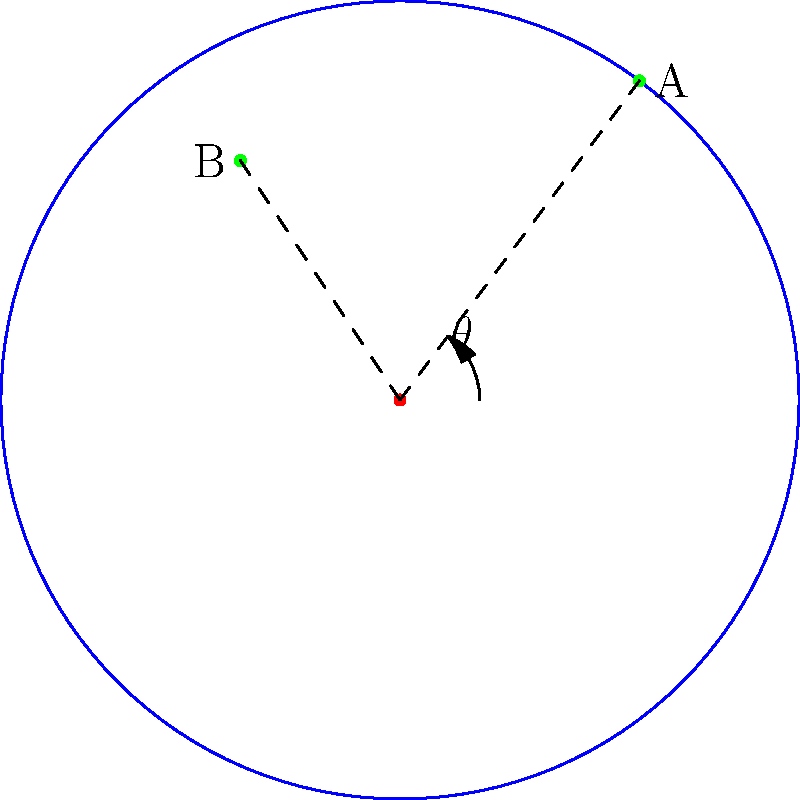On a circular football pitch with a radius of 50 meters, player A is positioned at coordinates (30, 40) and player B is at (-20, 30). Calculate the distance between the two players and the angle (in degrees) formed by the lines connecting each player to the center of the pitch. Let's approach this step-by-step:

1) First, we need to convert the given Cartesian coordinates to polar coordinates.

   For player A: $r_A = \sqrt{30^2 + 40^2} = 50$ meters, $\theta_A = \tan^{-1}(\frac{40}{30}) \approx 53.13°$
   For player B: $r_B = \sqrt{(-20)^2 + 30^2} = 36.06$ meters, $\theta_B = \tan^{-1}(\frac{30}{-20}) + 180° \approx 123.69°$

2) To find the distance between A and B, we can use the law of cosines:

   $d^2 = r_A^2 + r_B^2 - 2r_Ar_B\cos(\theta_B - \theta_A)$

   $d^2 = 50^2 + 36.06^2 - 2(50)(36.06)\cos(123.69° - 53.13°)$
   $d^2 = 2500 + 1300.32 - 3606\cos(70.56°)$
   $d^2 = 3800.32 - 3606(0.3338) = 2596.52$

   $d = \sqrt{2596.52} \approx 50.96$ meters

3) The angle formed at the center is simply the difference between the two angles:

   $\theta = \theta_B - \theta_A = 123.69° - 53.13° = 70.56°$

Therefore, the distance between the players is approximately 50.96 meters, and the angle formed at the center is 70.56°.
Answer: Distance: 50.96 m, Angle: 70.56° 